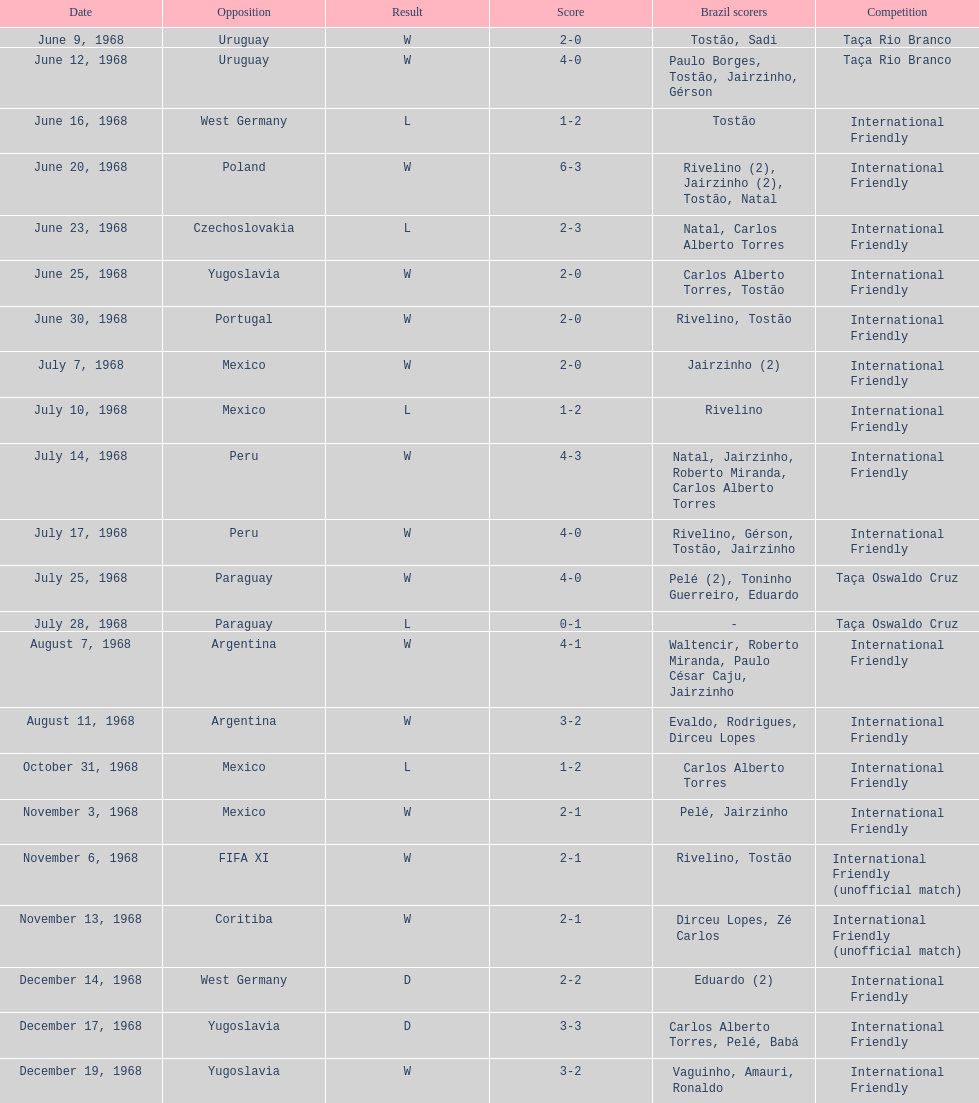How many times did brazil score during the game on november 6th? 2. Would you mind parsing the complete table? {'header': ['Date', 'Opposition', 'Result', 'Score', 'Brazil scorers', 'Competition'], 'rows': [['June 9, 1968', 'Uruguay', 'W', '2-0', 'Tostão, Sadi', 'Taça Rio Branco'], ['June 12, 1968', 'Uruguay', 'W', '4-0', 'Paulo Borges, Tostão, Jairzinho, Gérson', 'Taça Rio Branco'], ['June 16, 1968', 'West Germany', 'L', '1-2', 'Tostão', 'International Friendly'], ['June 20, 1968', 'Poland', 'W', '6-3', 'Rivelino (2), Jairzinho (2), Tostão, Natal', 'International Friendly'], ['June 23, 1968', 'Czechoslovakia', 'L', '2-3', 'Natal, Carlos Alberto Torres', 'International Friendly'], ['June 25, 1968', 'Yugoslavia', 'W', '2-0', 'Carlos Alberto Torres, Tostão', 'International Friendly'], ['June 30, 1968', 'Portugal', 'W', '2-0', 'Rivelino, Tostão', 'International Friendly'], ['July 7, 1968', 'Mexico', 'W', '2-0', 'Jairzinho (2)', 'International Friendly'], ['July 10, 1968', 'Mexico', 'L', '1-2', 'Rivelino', 'International Friendly'], ['July 14, 1968', 'Peru', 'W', '4-3', 'Natal, Jairzinho, Roberto Miranda, Carlos Alberto Torres', 'International Friendly'], ['July 17, 1968', 'Peru', 'W', '4-0', 'Rivelino, Gérson, Tostão, Jairzinho', 'International Friendly'], ['July 25, 1968', 'Paraguay', 'W', '4-0', 'Pelé (2), Toninho Guerreiro, Eduardo', 'Taça Oswaldo Cruz'], ['July 28, 1968', 'Paraguay', 'L', '0-1', '-', 'Taça Oswaldo Cruz'], ['August 7, 1968', 'Argentina', 'W', '4-1', 'Waltencir, Roberto Miranda, Paulo César Caju, Jairzinho', 'International Friendly'], ['August 11, 1968', 'Argentina', 'W', '3-2', 'Evaldo, Rodrigues, Dirceu Lopes', 'International Friendly'], ['October 31, 1968', 'Mexico', 'L', '1-2', 'Carlos Alberto Torres', 'International Friendly'], ['November 3, 1968', 'Mexico', 'W', '2-1', 'Pelé, Jairzinho', 'International Friendly'], ['November 6, 1968', 'FIFA XI', 'W', '2-1', 'Rivelino, Tostão', 'International Friendly (unofficial match)'], ['November 13, 1968', 'Coritiba', 'W', '2-1', 'Dirceu Lopes, Zé Carlos', 'International Friendly (unofficial match)'], ['December 14, 1968', 'West Germany', 'D', '2-2', 'Eduardo (2)', 'International Friendly'], ['December 17, 1968', 'Yugoslavia', 'D', '3-3', 'Carlos Alberto Torres, Pelé, Babá', 'International Friendly'], ['December 19, 1968', 'Yugoslavia', 'W', '3-2', 'Vaguinho, Amauri, Ronaldo', 'International Friendly']]} 